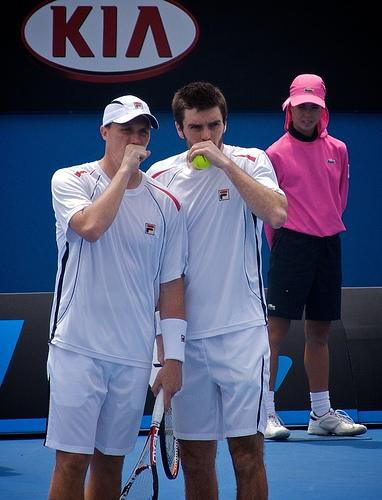Why are they covering their mouths? disappointment 